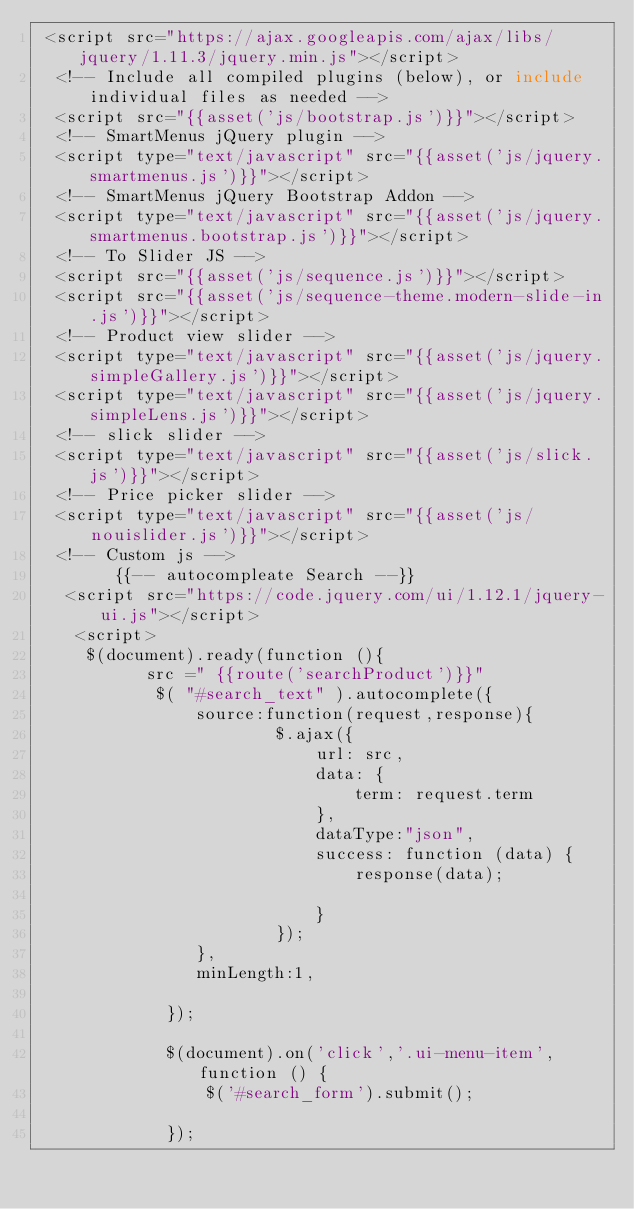<code> <loc_0><loc_0><loc_500><loc_500><_PHP_> <script src="https://ajax.googleapis.com/ajax/libs/jquery/1.11.3/jquery.min.js"></script>
  <!-- Include all compiled plugins (below), or include individual files as needed -->
  <script src="{{asset('js/bootstrap.js')}}"></script>  
  <!-- SmartMenus jQuery plugin -->
  <script type="text/javascript" src="{{asset('js/jquery.smartmenus.js')}}"></script>
  <!-- SmartMenus jQuery Bootstrap Addon -->
  <script type="text/javascript" src="{{asset('js/jquery.smartmenus.bootstrap.js')}}"></script>  
  <!-- To Slider JS -->
  <script src="{{asset('js/sequence.js')}}"></script>
  <script src="{{asset('js/sequence-theme.modern-slide-in.js')}}"></script>  
  <!-- Product view slider -->
  <script type="text/javascript" src="{{asset('js/jquery.simpleGallery.js')}}"></script>
  <script type="text/javascript" src="{{asset('js/jquery.simpleLens.js')}}"></script>
  <!-- slick slider -->
  <script type="text/javascript" src="{{asset('js/slick.js')}}"></script>
  <!-- Price picker slider -->
  <script type="text/javascript" src="{{asset('js/nouislider.js')}}"></script>
  <!-- Custom js -->
        {{-- autocompleate Search --}}
   <script src="https://code.jquery.com/ui/1.12.1/jquery-ui.js"></script>
    <script>
     $(document).ready(function (){
           src =" {{route('searchProduct')}}"
            $( "#search_text" ).autocomplete({
                source:function(request,response){
                        $.ajax({
                            url: src,
                            data: {
                                term: request.term
                            },
                            dataType:"json",
                            success: function (data) {
                                response(data);
                                
                            }
                        });
                },
                minLength:1,
               
             });

             $(document).on('click','.ui-menu-item', function () {
                 $('#search_form').submit();
                 
             });</code> 